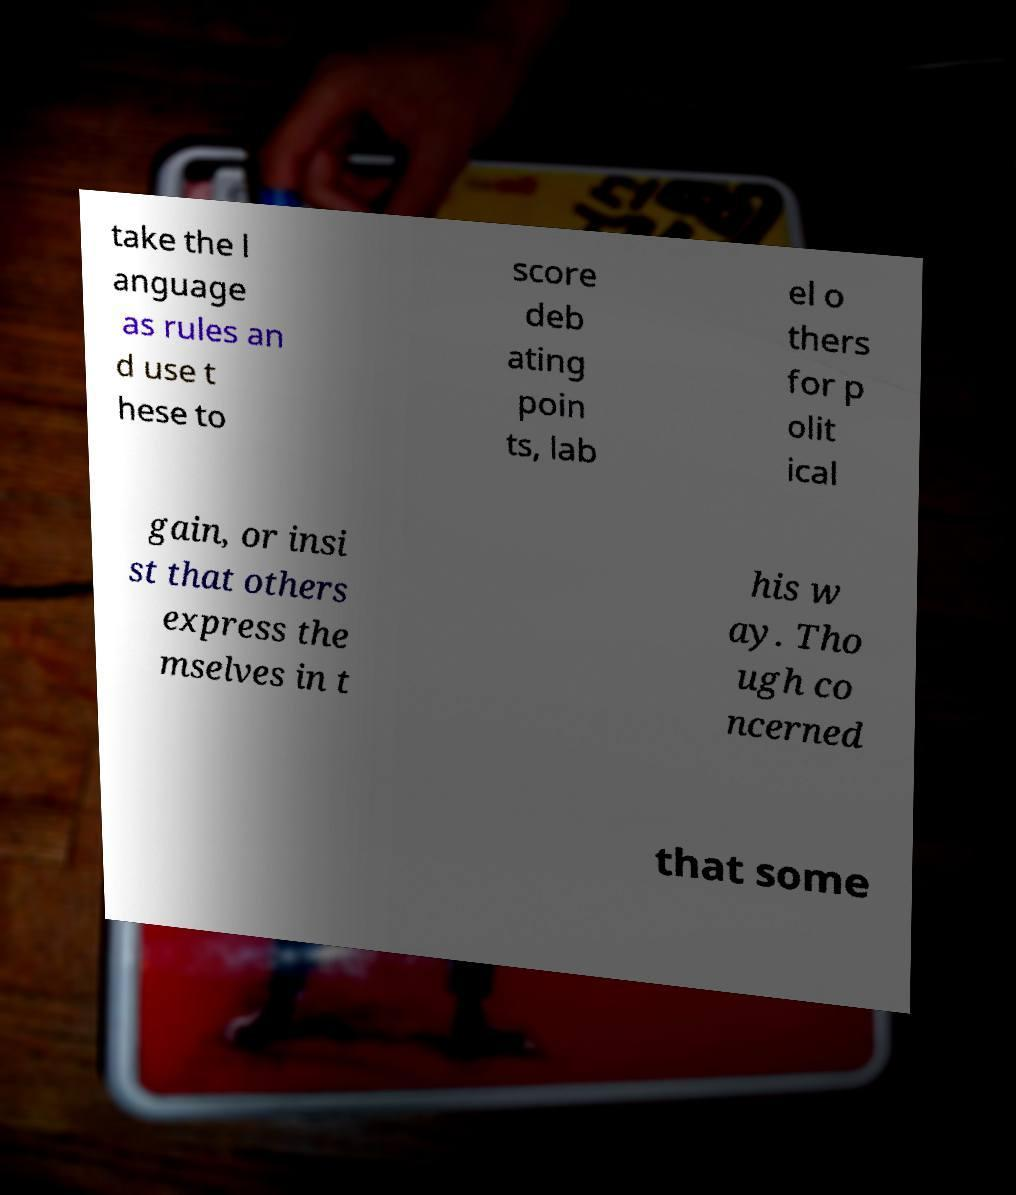Could you assist in decoding the text presented in this image and type it out clearly? take the l anguage as rules an d use t hese to score deb ating poin ts, lab el o thers for p olit ical gain, or insi st that others express the mselves in t his w ay. Tho ugh co ncerned that some 